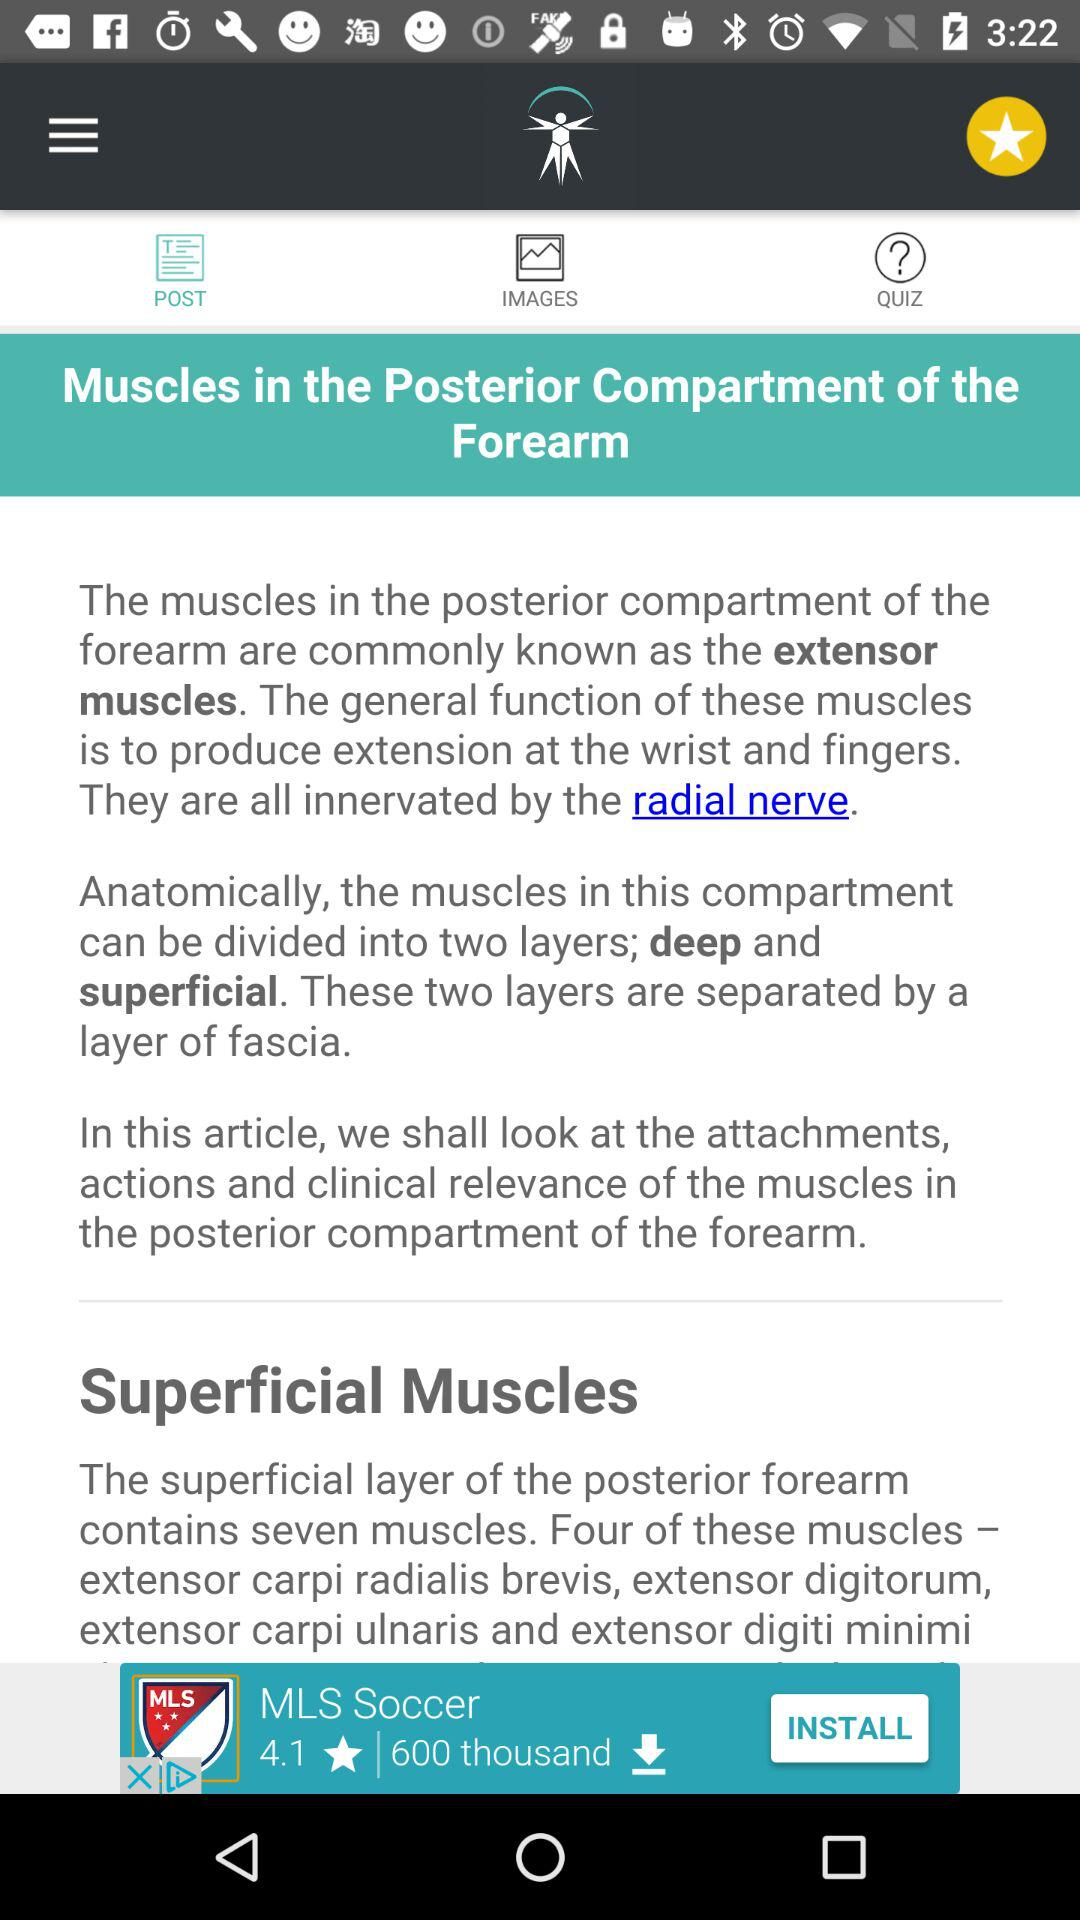What is the topic name? The topic name is "Muscles in the Posterior Compartment of the Forearm". 